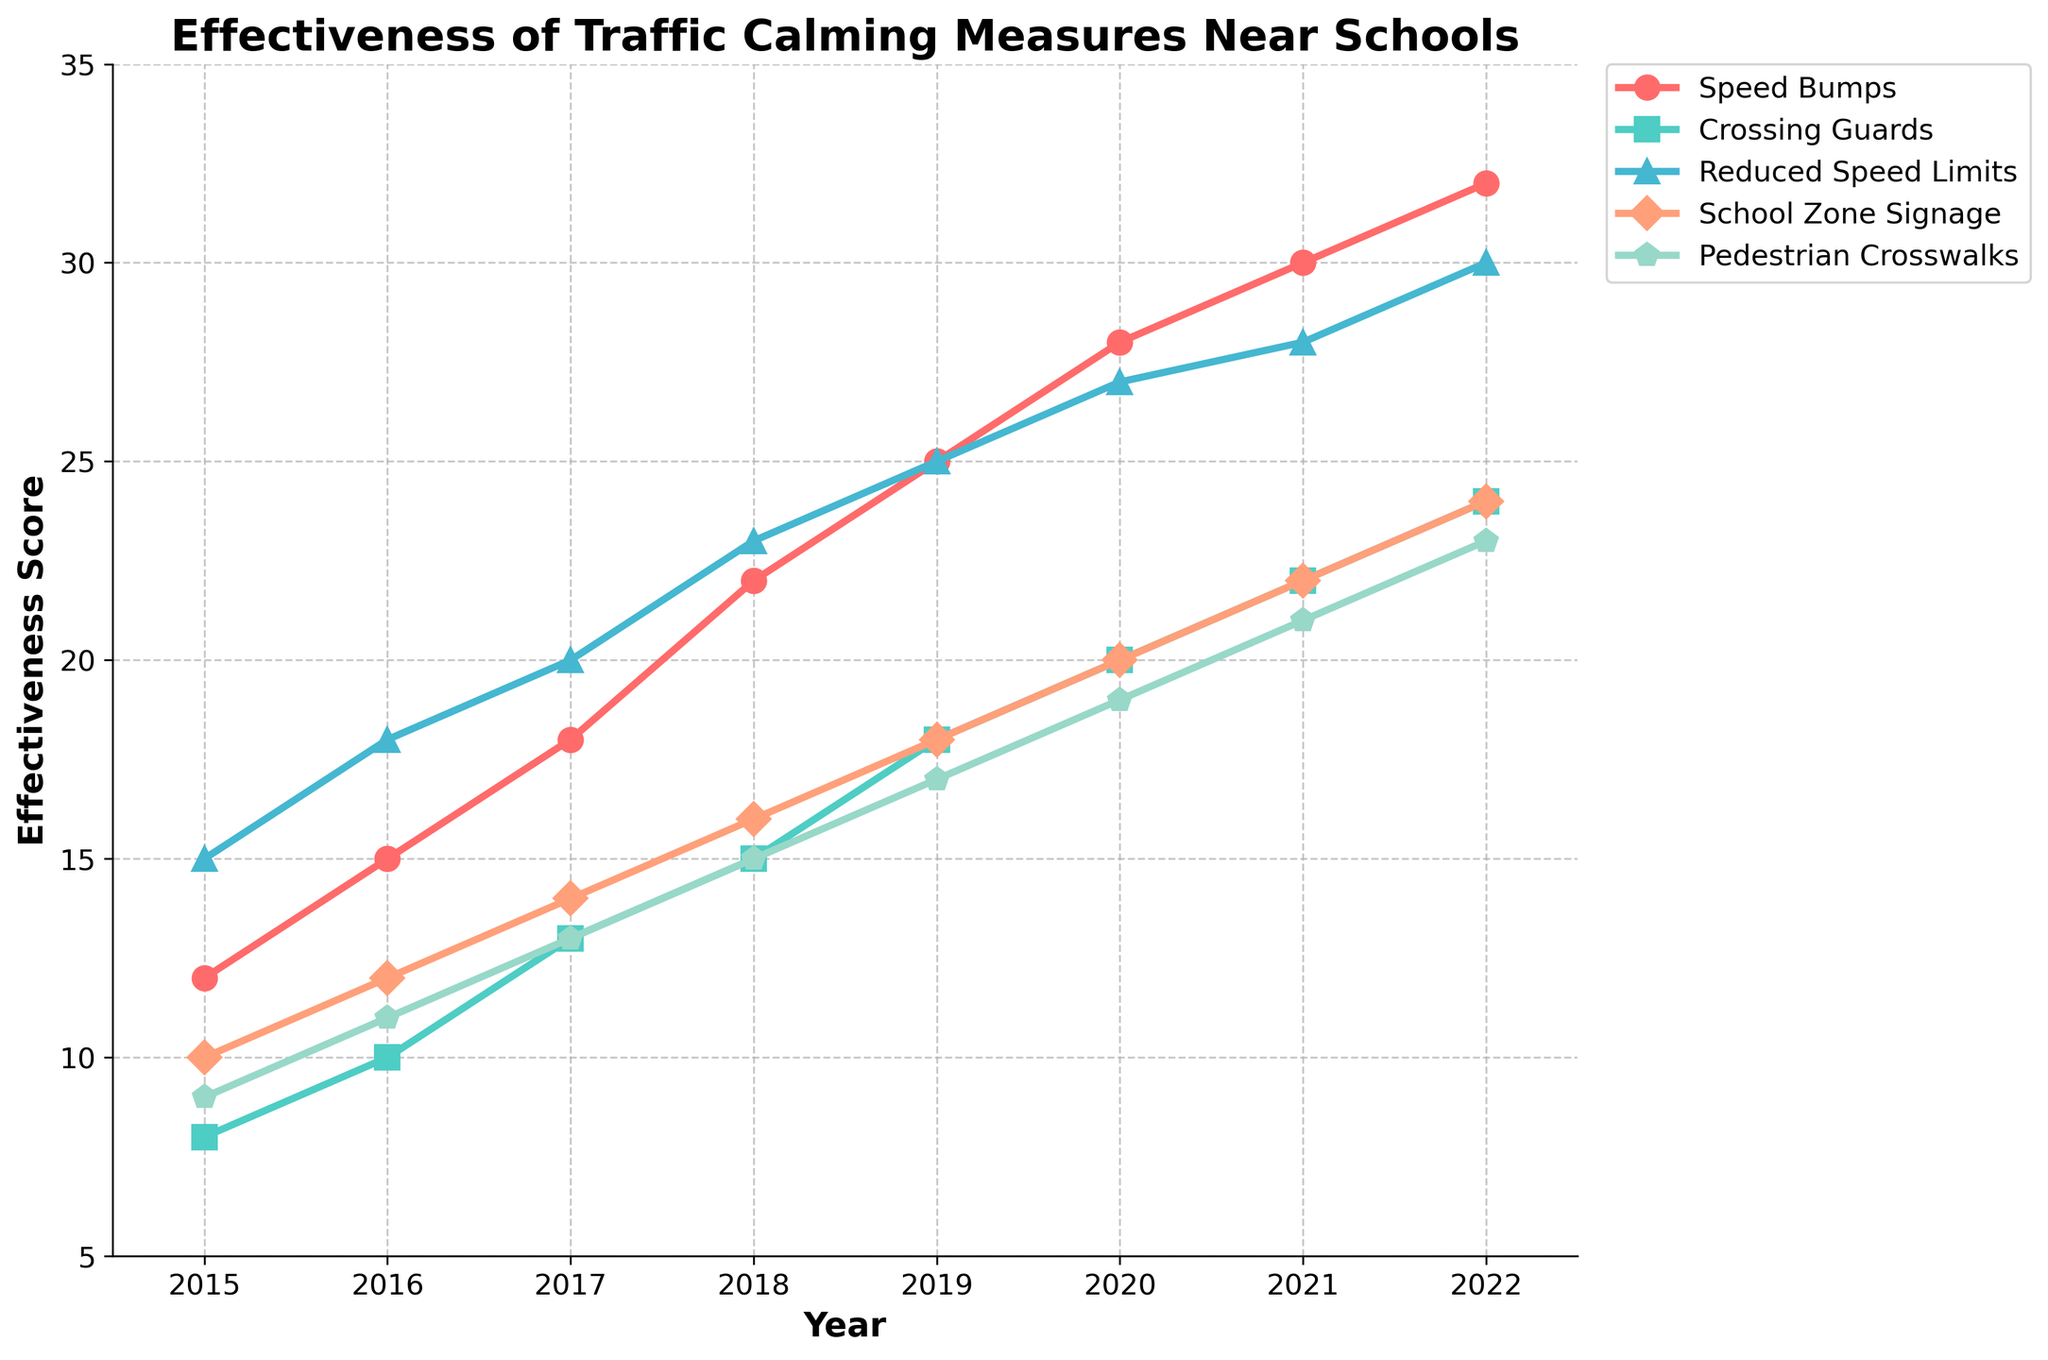What's the most effective traffic calming measure in 2022? In 2022, the measure with the highest effectiveness score is the most effective. By observing the endpoints of the lines, "Reduced Speed Limits" has the highest point at 30.
Answer: Reduced Speed Limits Which measure showed the largest overall increase in effectiveness from 2015 to 2022? Calculate the difference in effectiveness scores from 2015 to 2022 for each measure and identify the largest increase. "Speed Bumps" increased from 12 to 32, resulting in the largest increase of 20.
Answer: Speed Bumps Did any traffic calming measure maintain the same rate of increase each year? Check whether any measure increases by a constant value each year. "Reduced Speed Limits" consistently increases by 2 points every year from 2015 to 2022.
Answer: Reduced Speed Limits What is the average effectiveness score of Pedestrian Crosswalks over the years 2015 to 2022? Sum the effectiveness scores of Pedestrian Crosswalks for all years and divide by the number of years. (9 + 11 + 13 + 15 + 17 + 19 + 21 + 23) / 8 equals 16.
Answer: 16 In which year did School Zone Signage and Pedestrian Crosswalks have the same effectiveness score? Compare the effectiveness scores of School Zone Signage and Pedestrian Crosswalks for each year and identify the year with matching scores. Both measures show an effectiveness score of 10 in 2015.
Answer: 2015 Which two traffic calming measures had the smallest difference in effectiveness in 2021? Calculate the difference in effectiveness scores for every pair of measures in 2021 and identify the smallest difference. "Crossing Guards" and "Pedestrian Crosswalks" have the smallest difference of 1 (22 - 21).
Answer: Crossing Guards and Pedestrian Crosswalks Between 2018 to 2020, which measure had the sharpest increase in effectiveness? Calculate the increase in effectiveness from 2018 to 2020 for each measure and identify the sharpest. "Speed Bumps" increased from 22 to 28, a rise of 6 points.
Answer: Speed Bumps How many measures had an effectiveness score greater than 20 in 2020? Count the number of measures with effectiveness scores above 20 in the year 2020. "Speed Bumps", "Reduced Speed Limits", and "Pedestrian Crosswalks" have scores above 20.
Answer: Three measures Which measure had the least effectiveness in 2017? Identify the measure with the lowest effectiveness score in 2017 by examining the values. "Crossing Guards" has the lowest effectiveness score of 13.
Answer: Crossing Guards 